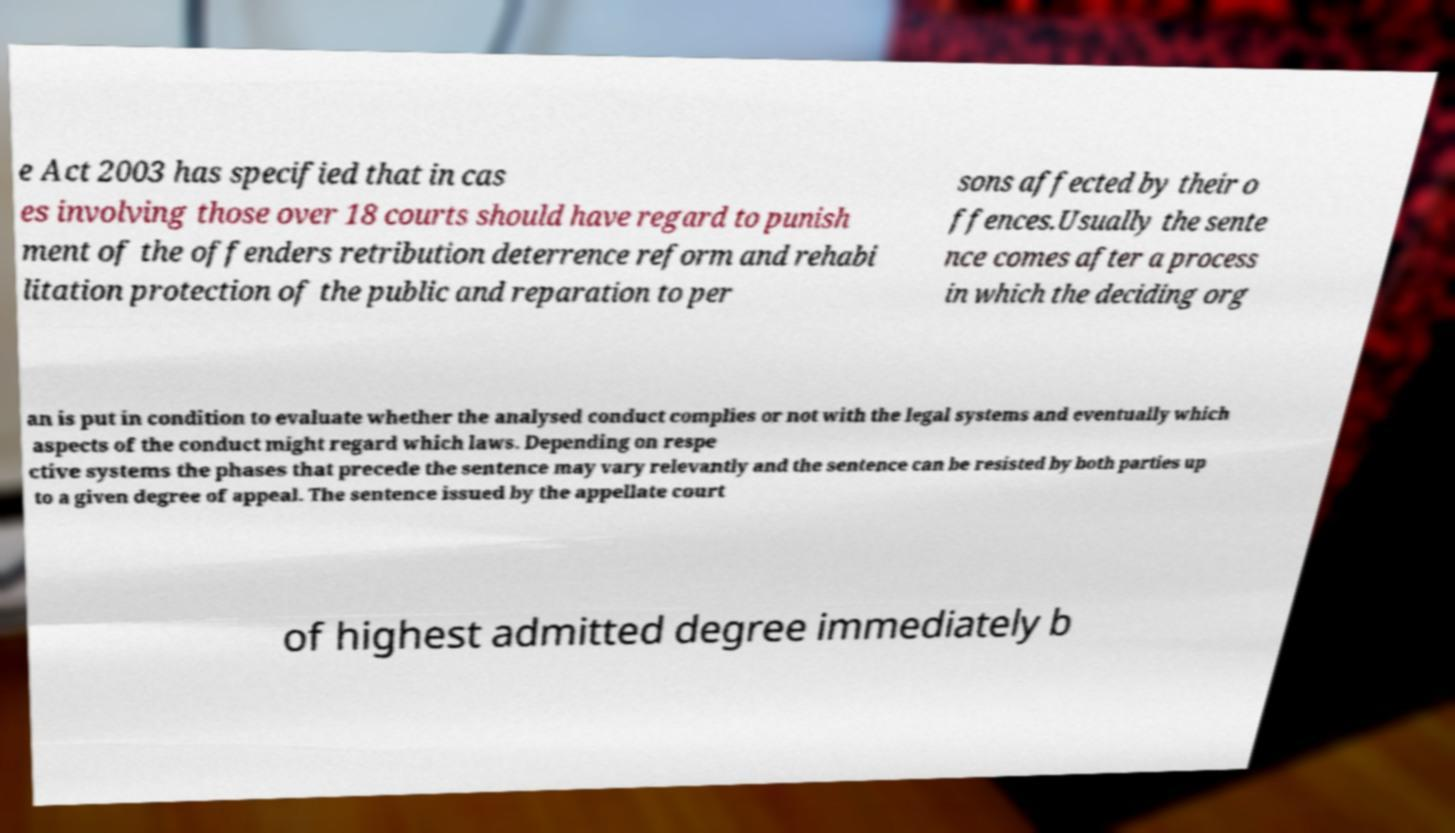Can you read and provide the text displayed in the image?This photo seems to have some interesting text. Can you extract and type it out for me? e Act 2003 has specified that in cas es involving those over 18 courts should have regard to punish ment of the offenders retribution deterrence reform and rehabi litation protection of the public and reparation to per sons affected by their o ffences.Usually the sente nce comes after a process in which the deciding org an is put in condition to evaluate whether the analysed conduct complies or not with the legal systems and eventually which aspects of the conduct might regard which laws. Depending on respe ctive systems the phases that precede the sentence may vary relevantly and the sentence can be resisted by both parties up to a given degree of appeal. The sentence issued by the appellate court of highest admitted degree immediately b 